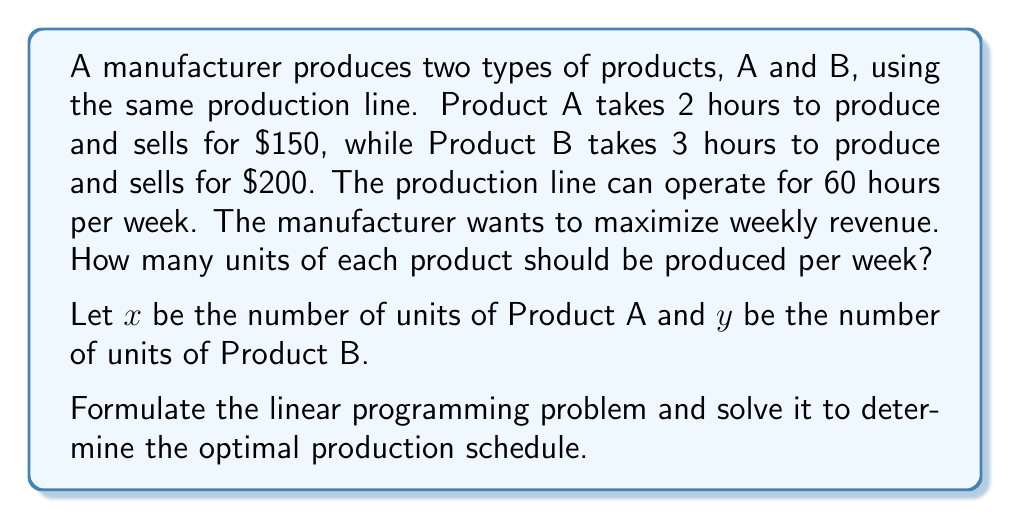Solve this math problem. 1. Formulate the objective function:
   Maximize revenue: $Z = 150x + 200y$

2. Identify constraints:
   Time constraint: $2x + 3y \leq 60$ (total production time cannot exceed 60 hours)
   Non-negativity: $x \geq 0$, $y \geq 0$

3. Graph the feasible region:
   [asy]
   import geometry;
   
   size(200);
   
   real xmax = 35;
   real ymax = 25;
   
   draw((0,0)--(xmax,0)--(xmax,ymax)--(0,ymax)--cycle);
   draw((0,20)--(30,0), blue);
   
   label("$2x + 3y = 60$", (15,10), NE, blue);
   label("$x$", (xmax,0), S);
   label("$y$", (0,ymax), W);
   label("(0,20)", (0,20), W);
   label("(30,0)", (30,0), S);
   
   dot((0,20));
   dot((30,0));
   [/asy]

4. Identify corner points:
   (0,0), (30,0), (0,20)

5. Evaluate objective function at corner points:
   At (0,0): $Z = 150(0) + 200(0) = 0$
   At (30,0): $Z = 150(30) + 200(0) = 4500$
   At (0,20): $Z = 150(0) + 200(20) = 4000$

6. The maximum value occurs at (30,0), which means producing 30 units of Product A and 0 units of Product B.
Answer: 30 units of Product A, 0 units of Product B 